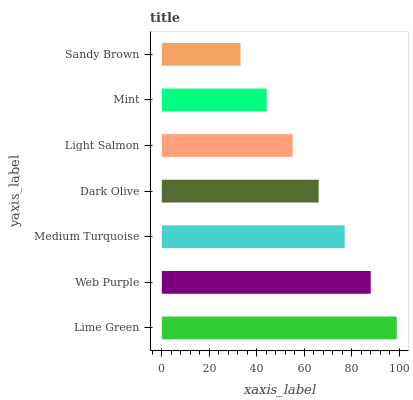Is Sandy Brown the minimum?
Answer yes or no. Yes. Is Lime Green the maximum?
Answer yes or no. Yes. Is Web Purple the minimum?
Answer yes or no. No. Is Web Purple the maximum?
Answer yes or no. No. Is Lime Green greater than Web Purple?
Answer yes or no. Yes. Is Web Purple less than Lime Green?
Answer yes or no. Yes. Is Web Purple greater than Lime Green?
Answer yes or no. No. Is Lime Green less than Web Purple?
Answer yes or no. No. Is Dark Olive the high median?
Answer yes or no. Yes. Is Dark Olive the low median?
Answer yes or no. Yes. Is Sandy Brown the high median?
Answer yes or no. No. Is Lime Green the low median?
Answer yes or no. No. 